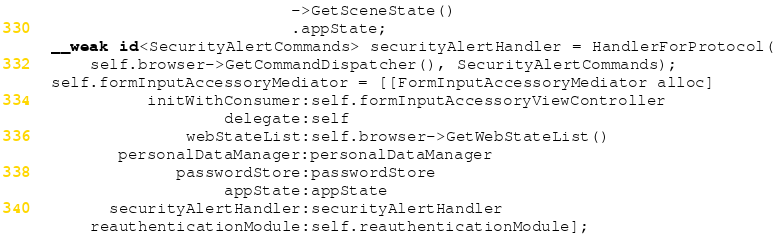Convert code to text. <code><loc_0><loc_0><loc_500><loc_500><_ObjectiveC_>                           ->GetSceneState()
                           .appState;
  __weak id<SecurityAlertCommands> securityAlertHandler = HandlerForProtocol(
      self.browser->GetCommandDispatcher(), SecurityAlertCommands);
  self.formInputAccessoryMediator = [[FormInputAccessoryMediator alloc]
            initWithConsumer:self.formInputAccessoryViewController
                    delegate:self
                webStateList:self.browser->GetWebStateList()
         personalDataManager:personalDataManager
               passwordStore:passwordStore
                    appState:appState
        securityAlertHandler:securityAlertHandler
      reauthenticationModule:self.reauthenticationModule];</code> 